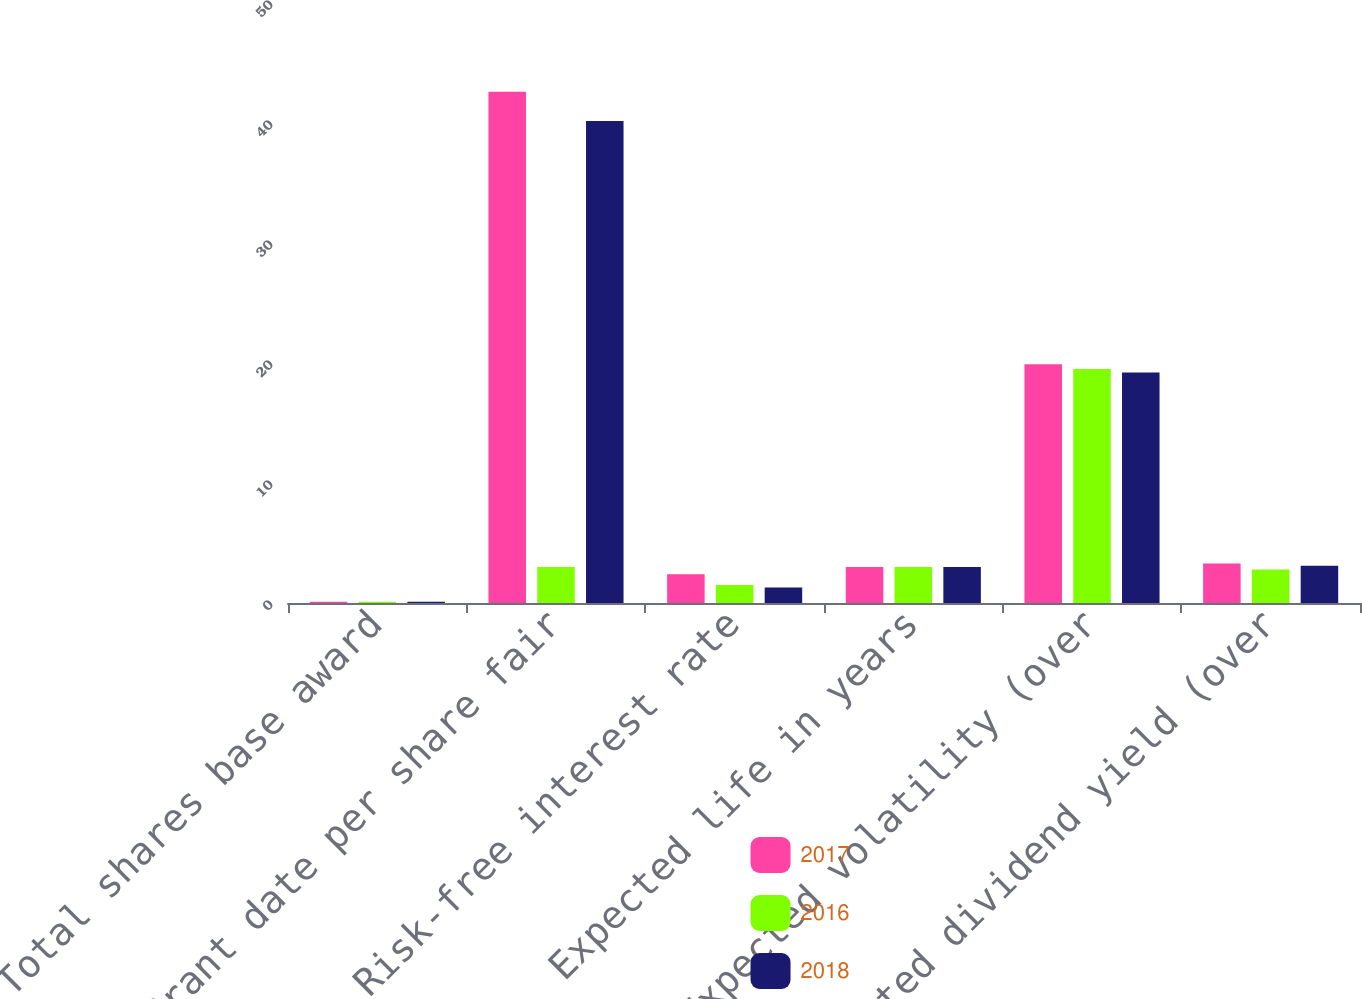Convert chart. <chart><loc_0><loc_0><loc_500><loc_500><stacked_bar_chart><ecel><fcel>Total shares base award<fcel>Grant date per share fair<fcel>Risk-free interest rate<fcel>Expected life in years<fcel>Expected volatility (over<fcel>Expected dividend yield (over<nl><fcel>2017<fcel>0.1<fcel>42.6<fcel>2.4<fcel>3<fcel>19.9<fcel>3.3<nl><fcel>2016<fcel>0.1<fcel>3<fcel>1.5<fcel>3<fcel>19.5<fcel>2.8<nl><fcel>2018<fcel>0.1<fcel>40.16<fcel>1.3<fcel>3<fcel>19.2<fcel>3.1<nl></chart> 